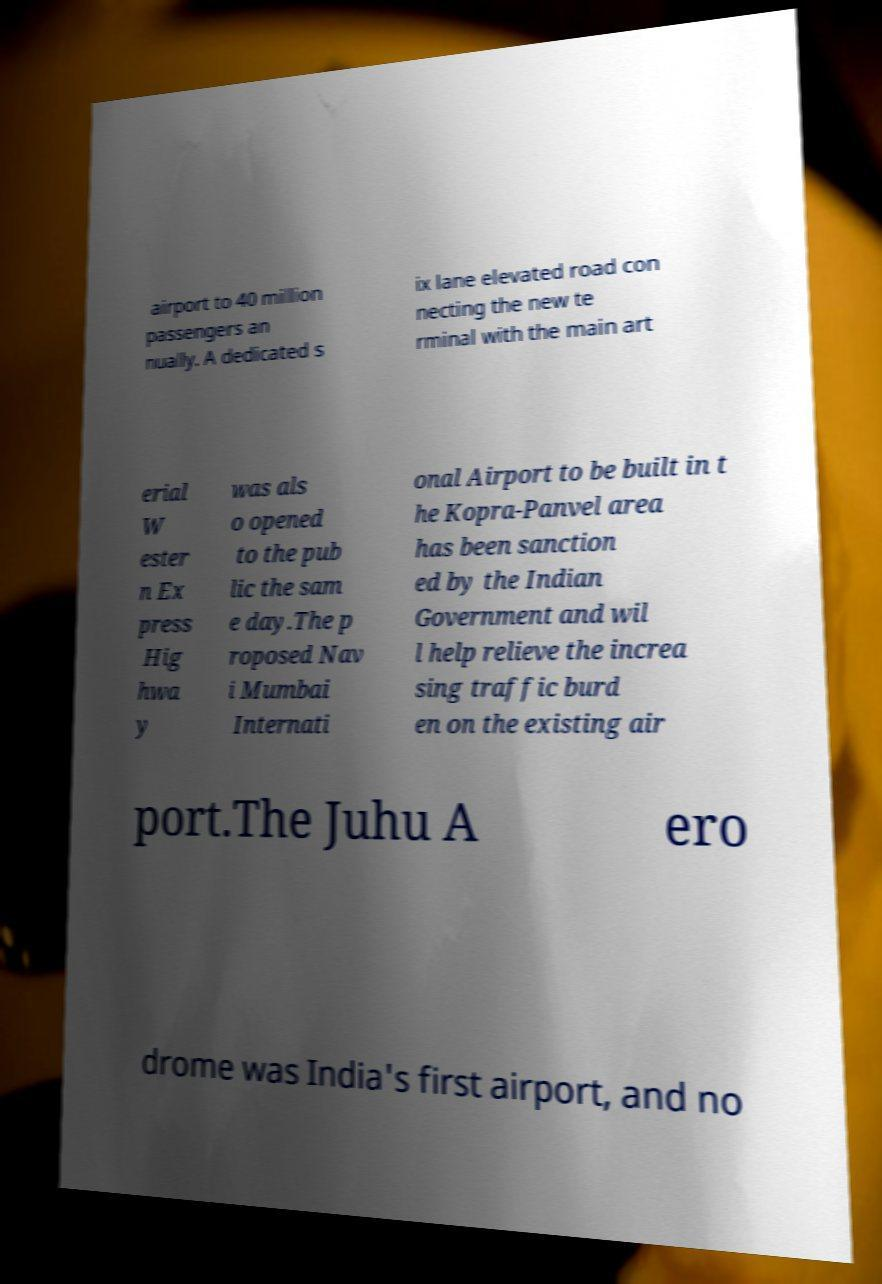For documentation purposes, I need the text within this image transcribed. Could you provide that? airport to 40 million passengers an nually. A dedicated s ix lane elevated road con necting the new te rminal with the main art erial W ester n Ex press Hig hwa y was als o opened to the pub lic the sam e day.The p roposed Nav i Mumbai Internati onal Airport to be built in t he Kopra-Panvel area has been sanction ed by the Indian Government and wil l help relieve the increa sing traffic burd en on the existing air port.The Juhu A ero drome was India's first airport, and no 